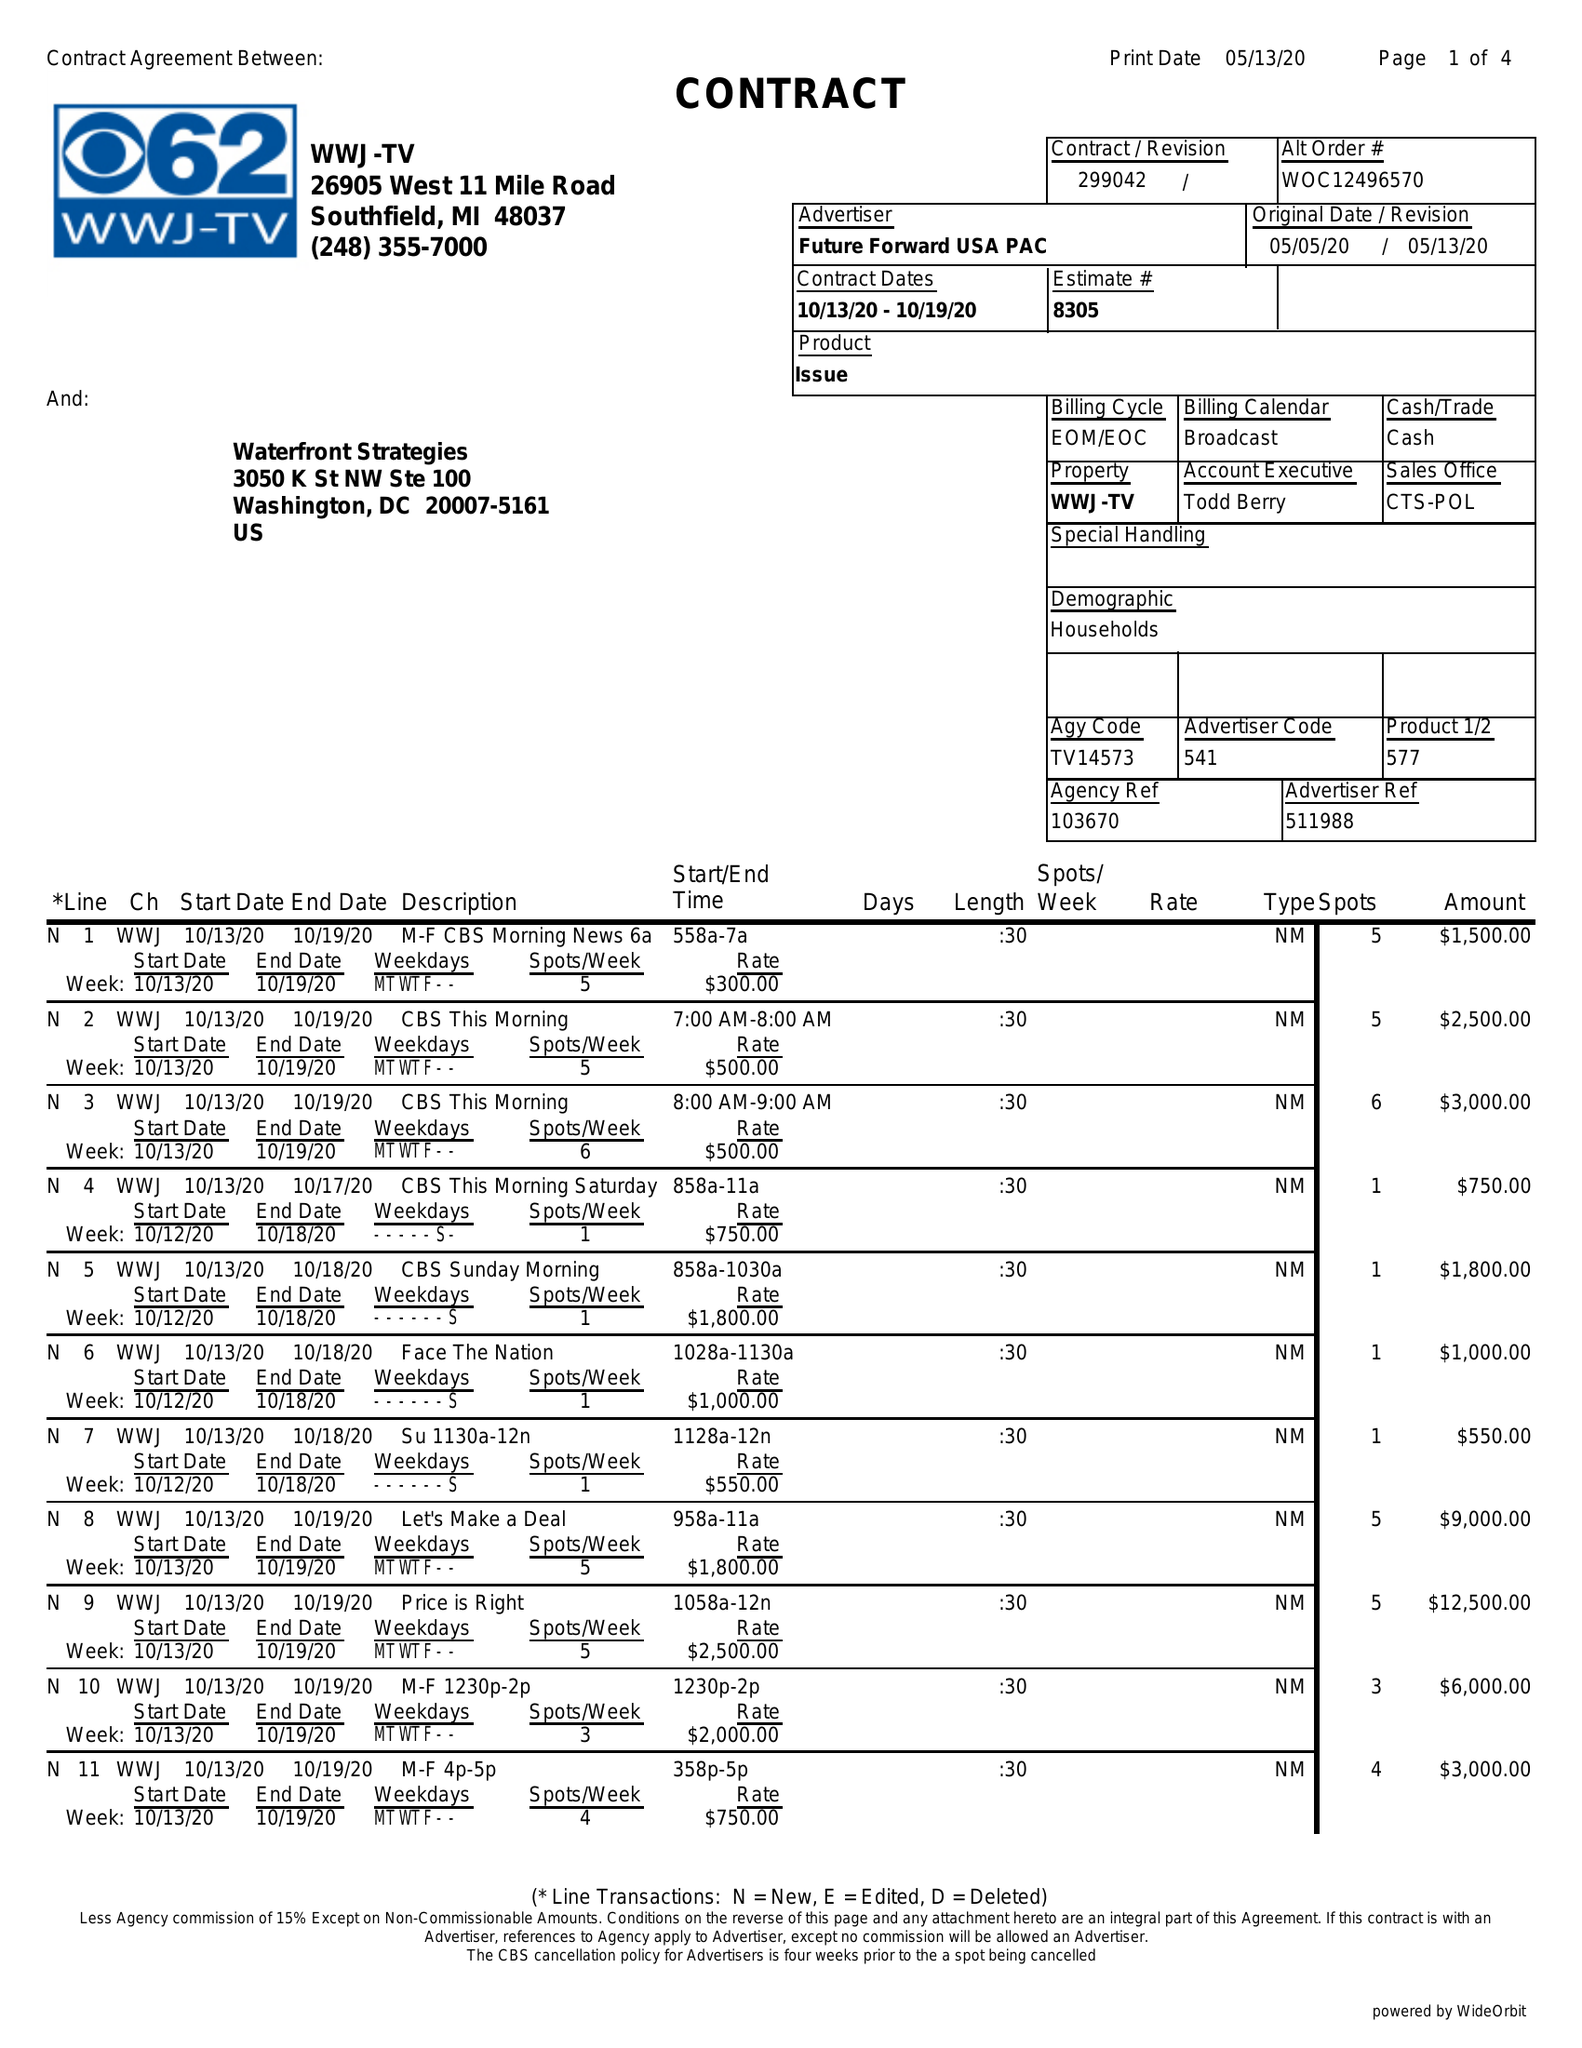What is the value for the gross_amount?
Answer the question using a single word or phrase. 98850.00 